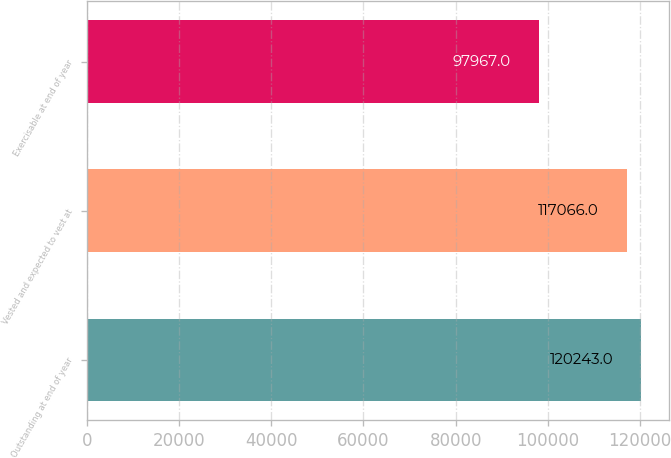Convert chart to OTSL. <chart><loc_0><loc_0><loc_500><loc_500><bar_chart><fcel>Outstanding at end of year<fcel>Vested and expected to vest at<fcel>Exercisable at end of year<nl><fcel>120243<fcel>117066<fcel>97967<nl></chart> 